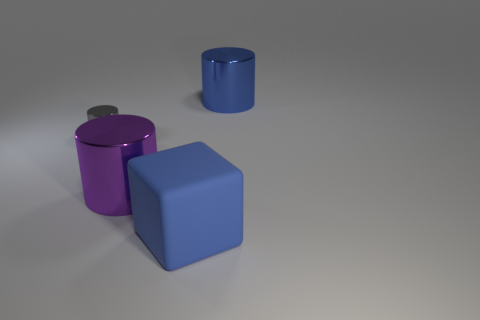Add 3 big blocks. How many objects exist? 7 Subtract all cylinders. How many objects are left? 1 Add 1 big blue metal things. How many big blue metal things are left? 2 Add 4 large shiny objects. How many large shiny objects exist? 6 Subtract 0 purple spheres. How many objects are left? 4 Subtract all purple metal cylinders. Subtract all blue cylinders. How many objects are left? 2 